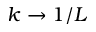Convert formula to latex. <formula><loc_0><loc_0><loc_500><loc_500>k \rightarrow 1 / L</formula> 